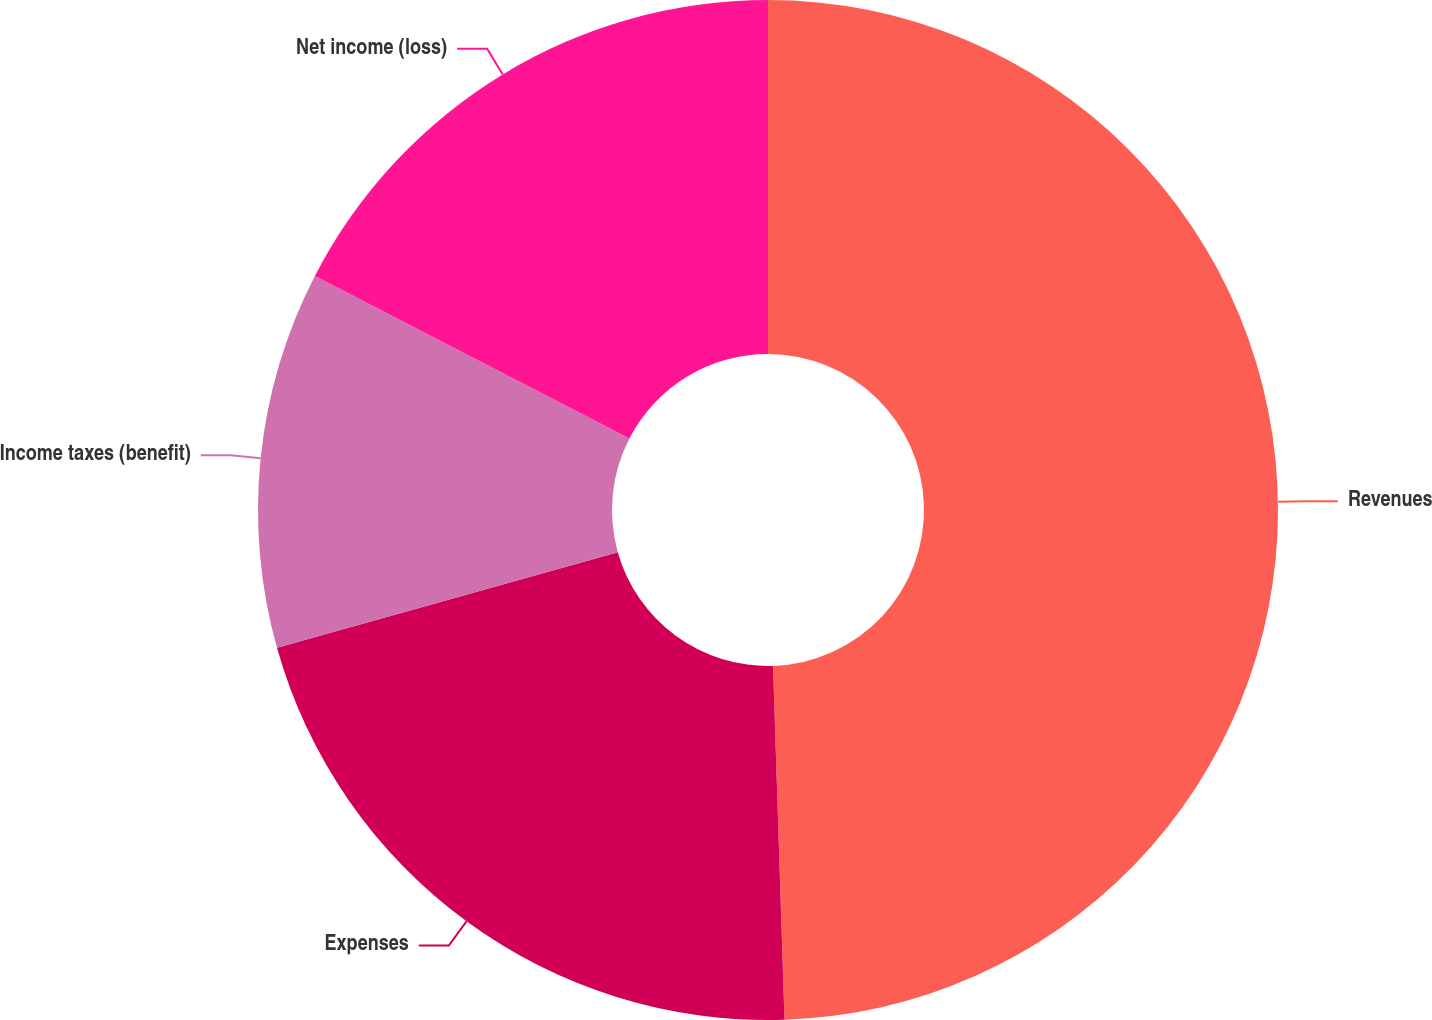<chart> <loc_0><loc_0><loc_500><loc_500><pie_chart><fcel>Revenues<fcel>Expenses<fcel>Income taxes (benefit)<fcel>Net income (loss)<nl><fcel>49.48%<fcel>21.16%<fcel>11.94%<fcel>17.41%<nl></chart> 